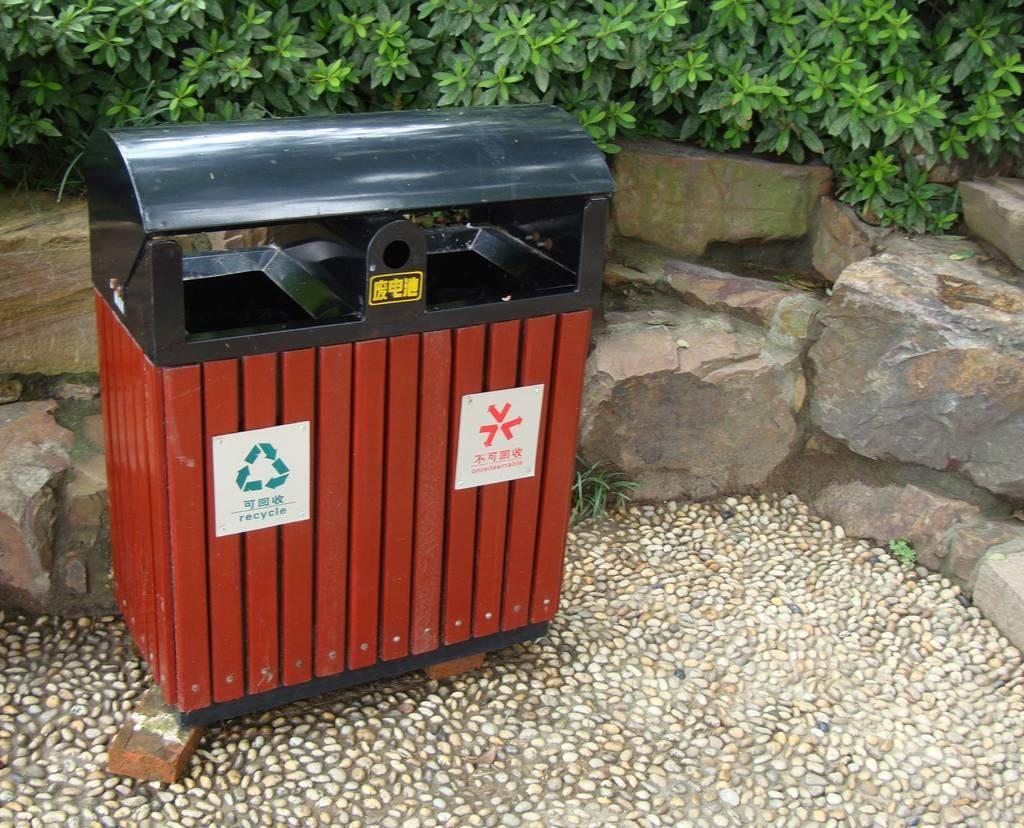<image>
Create a compact narrative representing the image presented. A waste container that has a bin for recycle, and a bin for trash attached to it. 